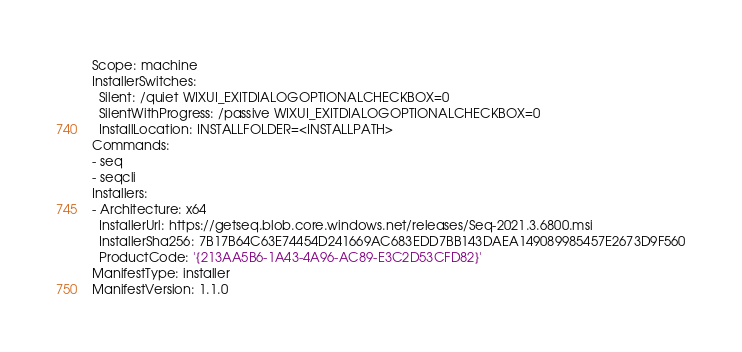Convert code to text. <code><loc_0><loc_0><loc_500><loc_500><_YAML_>Scope: machine
InstallerSwitches:
  Silent: /quiet WIXUI_EXITDIALOGOPTIONALCHECKBOX=0
  SilentWithProgress: /passive WIXUI_EXITDIALOGOPTIONALCHECKBOX=0
  InstallLocation: INSTALLFOLDER=<INSTALLPATH>
Commands:
- seq
- seqcli
Installers:
- Architecture: x64
  InstallerUrl: https://getseq.blob.core.windows.net/releases/Seq-2021.3.6800.msi
  InstallerSha256: 7B17B64C63E74454D241669AC683EDD7BB143DAEA149089985457E2673D9F560
  ProductCode: '{213AA5B6-1A43-4A96-AC89-E3C2D53CFD82}'
ManifestType: installer
ManifestVersion: 1.1.0
</code> 